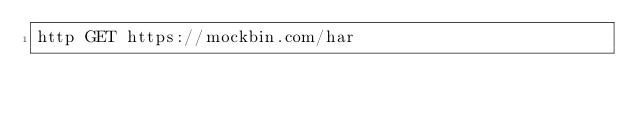<code> <loc_0><loc_0><loc_500><loc_500><_Bash_>http GET https://mockbin.com/har</code> 